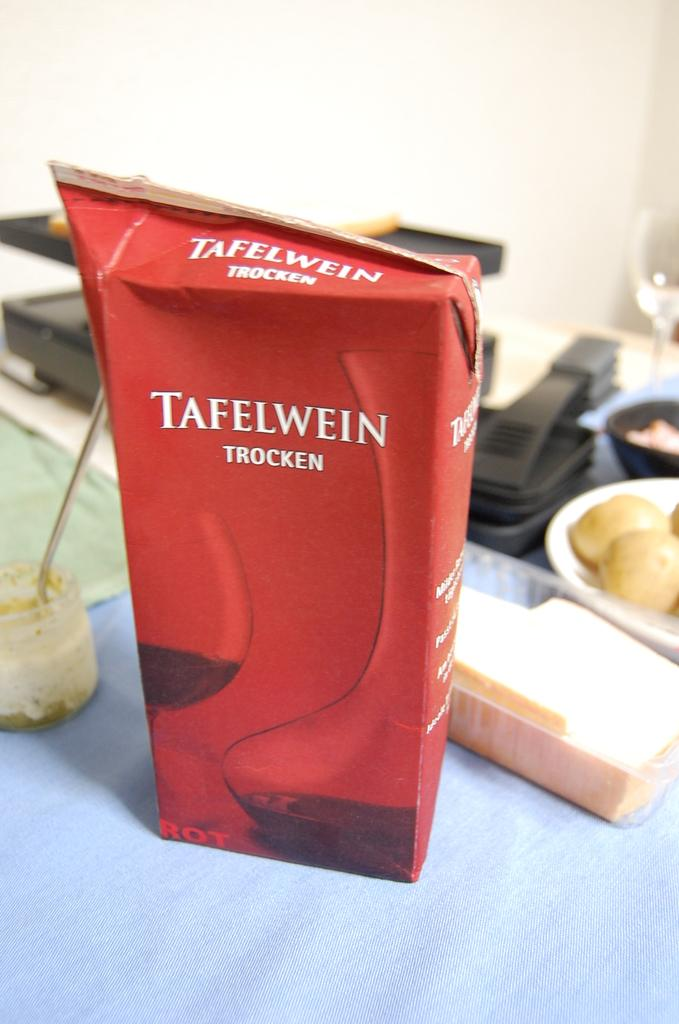What type of furniture is present in the image? There is a table in the image. What is placed on the table? There is a box, bowls, a glass, food items, and other objects on the table. What can be seen behind the table? There is a wall behind the table. What type of business is being conducted in the image? There is no indication of any business being conducted in the image. Can you see a thumb in the image? There is no thumb visible in the image. 